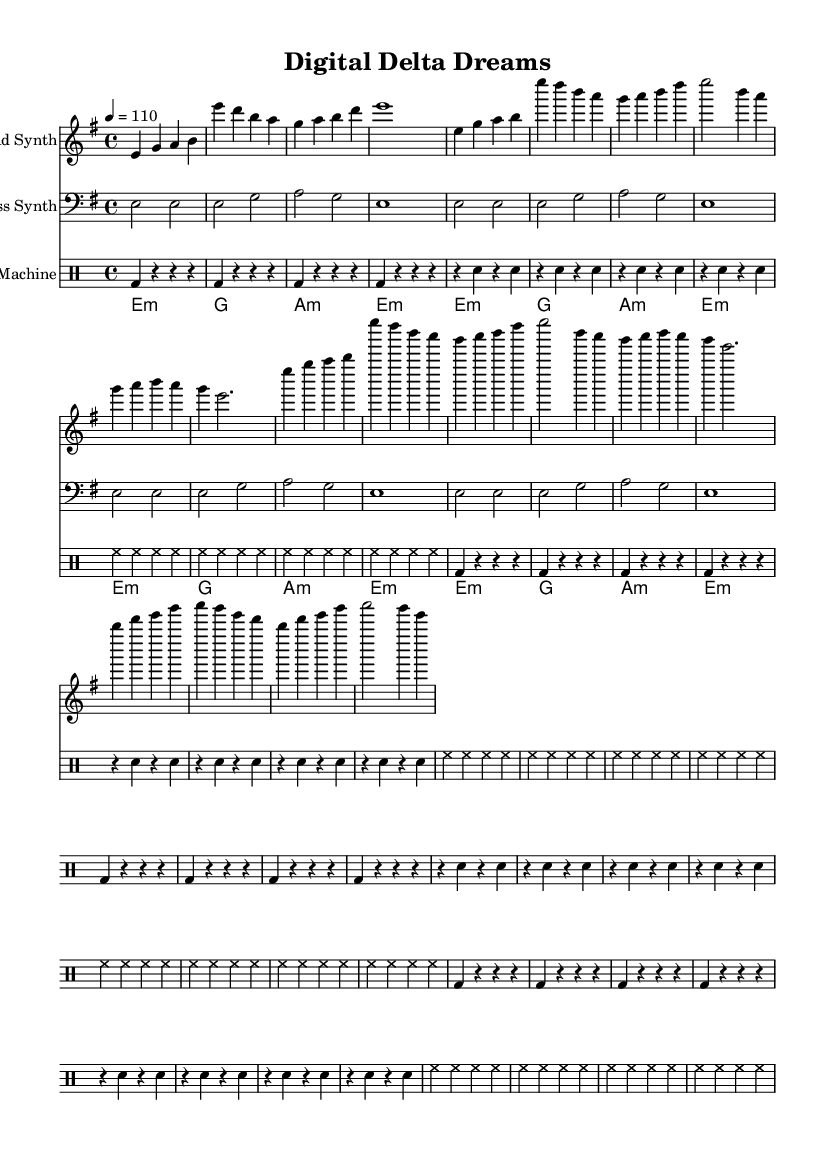What is the key signature of this music? The key signature is E minor, which has one sharp (F#). This can be identified in the global settings section, where the key is specified.
Answer: E minor What is the time signature of this music? The time signature is 4/4, indicating four beats per measure, as shown in the global settings section.
Answer: 4/4 What is the tempo marking for this piece? The tempo marking indicates a speed of 110 beats per minute, which is specified in the global settings.
Answer: 110 How many measures are in the lead synth part? The lead synth part contains a total of 16 measures. This can be counted from the introduction, verse, chorus, and bridge sections.
Answer: 16 What is the rhythm pattern of the bass synth? The bass synth has a consistent rhythm pattern of half notes and quarter notes throughout its part, which can be observed in the repeated segment.
Answer: Alternates between half and quarter notes Which instrument plays the drum part? The drum part is played by the drum machine, as indicated in the staff labeled for it.
Answer: Drum machine What type of chords are used in the pad synth section? The pad synth section uses minor and major chords, as indicated by the chord symbols in the chord mode.
Answer: Minor and Major chords 